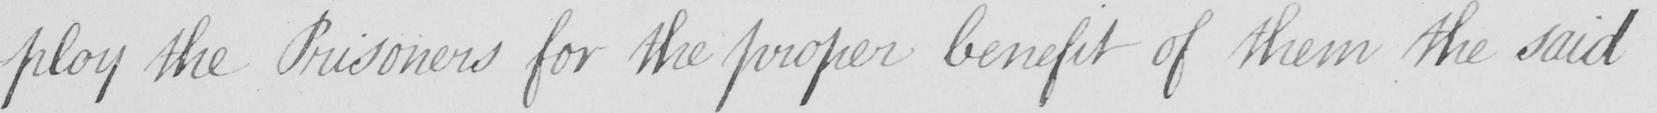Transcribe the text shown in this historical manuscript line. -ploy the Prisoners for the proper benefit of them the said 